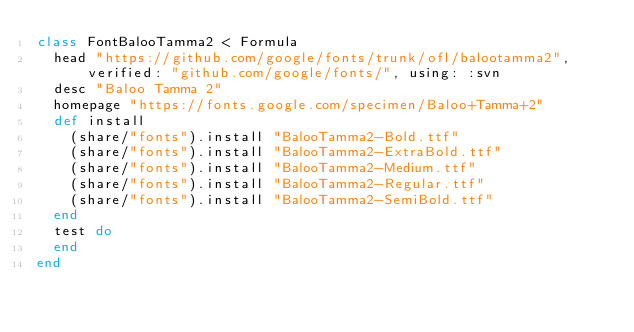Convert code to text. <code><loc_0><loc_0><loc_500><loc_500><_Ruby_>class FontBalooTamma2 < Formula
  head "https://github.com/google/fonts/trunk/ofl/balootamma2", verified: "github.com/google/fonts/", using: :svn
  desc "Baloo Tamma 2"
  homepage "https://fonts.google.com/specimen/Baloo+Tamma+2"
  def install
    (share/"fonts").install "BalooTamma2-Bold.ttf"
    (share/"fonts").install "BalooTamma2-ExtraBold.ttf"
    (share/"fonts").install "BalooTamma2-Medium.ttf"
    (share/"fonts").install "BalooTamma2-Regular.ttf"
    (share/"fonts").install "BalooTamma2-SemiBold.ttf"
  end
  test do
  end
end
</code> 